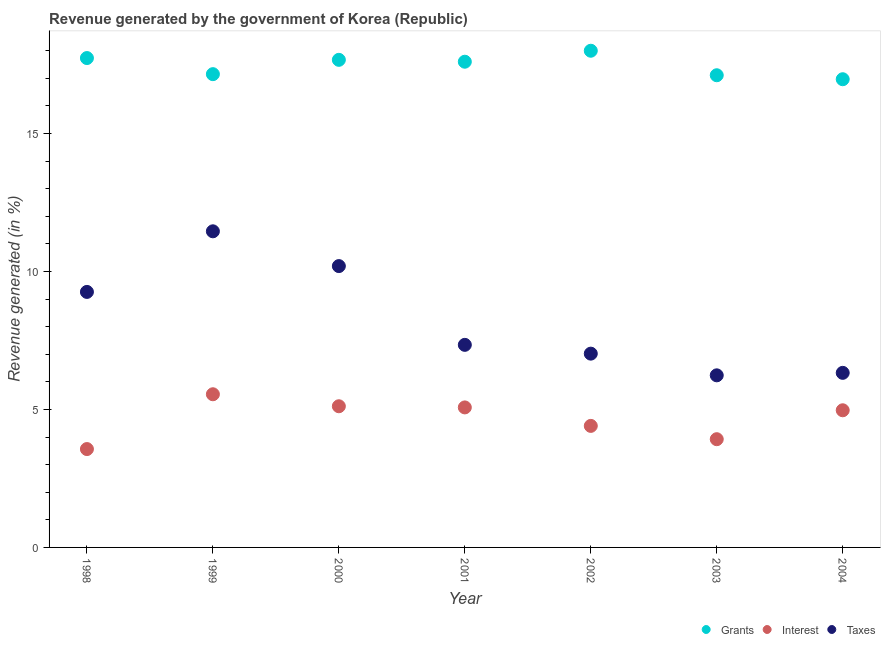Is the number of dotlines equal to the number of legend labels?
Your response must be concise. Yes. What is the percentage of revenue generated by interest in 2002?
Your answer should be compact. 4.4. Across all years, what is the maximum percentage of revenue generated by interest?
Provide a short and direct response. 5.55. Across all years, what is the minimum percentage of revenue generated by interest?
Provide a short and direct response. 3.56. In which year was the percentage of revenue generated by interest minimum?
Offer a very short reply. 1998. What is the total percentage of revenue generated by grants in the graph?
Your answer should be compact. 122.23. What is the difference between the percentage of revenue generated by grants in 2000 and that in 2002?
Offer a terse response. -0.33. What is the difference between the percentage of revenue generated by taxes in 2001 and the percentage of revenue generated by grants in 1998?
Your answer should be compact. -10.39. What is the average percentage of revenue generated by interest per year?
Offer a very short reply. 4.66. In the year 1999, what is the difference between the percentage of revenue generated by grants and percentage of revenue generated by interest?
Your answer should be very brief. 11.6. What is the ratio of the percentage of revenue generated by interest in 1999 to that in 2000?
Offer a terse response. 1.08. Is the percentage of revenue generated by taxes in 2000 less than that in 2002?
Your response must be concise. No. Is the difference between the percentage of revenue generated by taxes in 1998 and 2004 greater than the difference between the percentage of revenue generated by interest in 1998 and 2004?
Make the answer very short. Yes. What is the difference between the highest and the second highest percentage of revenue generated by grants?
Provide a short and direct response. 0.27. What is the difference between the highest and the lowest percentage of revenue generated by grants?
Make the answer very short. 1.03. Is the sum of the percentage of revenue generated by taxes in 2001 and 2003 greater than the maximum percentage of revenue generated by interest across all years?
Ensure brevity in your answer.  Yes. Is the percentage of revenue generated by grants strictly less than the percentage of revenue generated by taxes over the years?
Provide a succinct answer. No. How many dotlines are there?
Offer a terse response. 3. How many years are there in the graph?
Offer a very short reply. 7. Does the graph contain grids?
Your answer should be very brief. No. Where does the legend appear in the graph?
Keep it short and to the point. Bottom right. How many legend labels are there?
Your response must be concise. 3. What is the title of the graph?
Offer a terse response. Revenue generated by the government of Korea (Republic). Does "Ages 20-50" appear as one of the legend labels in the graph?
Your answer should be compact. No. What is the label or title of the Y-axis?
Your answer should be very brief. Revenue generated (in %). What is the Revenue generated (in %) in Grants in 1998?
Ensure brevity in your answer.  17.73. What is the Revenue generated (in %) of Interest in 1998?
Your answer should be very brief. 3.56. What is the Revenue generated (in %) in Taxes in 1998?
Provide a short and direct response. 9.26. What is the Revenue generated (in %) of Grants in 1999?
Ensure brevity in your answer.  17.15. What is the Revenue generated (in %) in Interest in 1999?
Provide a succinct answer. 5.55. What is the Revenue generated (in %) in Taxes in 1999?
Provide a succinct answer. 11.46. What is the Revenue generated (in %) in Grants in 2000?
Keep it short and to the point. 17.67. What is the Revenue generated (in %) of Interest in 2000?
Provide a short and direct response. 5.12. What is the Revenue generated (in %) of Taxes in 2000?
Your answer should be compact. 10.2. What is the Revenue generated (in %) in Grants in 2001?
Provide a succinct answer. 17.6. What is the Revenue generated (in %) in Interest in 2001?
Your answer should be compact. 5.07. What is the Revenue generated (in %) of Taxes in 2001?
Your answer should be compact. 7.34. What is the Revenue generated (in %) of Grants in 2002?
Offer a very short reply. 18. What is the Revenue generated (in %) of Interest in 2002?
Your answer should be compact. 4.4. What is the Revenue generated (in %) of Taxes in 2002?
Your answer should be compact. 7.02. What is the Revenue generated (in %) in Grants in 2003?
Your answer should be very brief. 17.11. What is the Revenue generated (in %) of Interest in 2003?
Provide a short and direct response. 3.92. What is the Revenue generated (in %) of Taxes in 2003?
Keep it short and to the point. 6.24. What is the Revenue generated (in %) in Grants in 2004?
Provide a succinct answer. 16.97. What is the Revenue generated (in %) in Interest in 2004?
Offer a very short reply. 4.97. What is the Revenue generated (in %) of Taxes in 2004?
Offer a very short reply. 6.33. Across all years, what is the maximum Revenue generated (in %) of Grants?
Your answer should be very brief. 18. Across all years, what is the maximum Revenue generated (in %) of Interest?
Keep it short and to the point. 5.55. Across all years, what is the maximum Revenue generated (in %) in Taxes?
Your response must be concise. 11.46. Across all years, what is the minimum Revenue generated (in %) of Grants?
Your answer should be compact. 16.97. Across all years, what is the minimum Revenue generated (in %) in Interest?
Provide a succinct answer. 3.56. Across all years, what is the minimum Revenue generated (in %) in Taxes?
Offer a very short reply. 6.24. What is the total Revenue generated (in %) of Grants in the graph?
Keep it short and to the point. 122.23. What is the total Revenue generated (in %) in Interest in the graph?
Your response must be concise. 32.6. What is the total Revenue generated (in %) of Taxes in the graph?
Ensure brevity in your answer.  57.83. What is the difference between the Revenue generated (in %) of Grants in 1998 and that in 1999?
Your answer should be very brief. 0.58. What is the difference between the Revenue generated (in %) in Interest in 1998 and that in 1999?
Offer a terse response. -1.99. What is the difference between the Revenue generated (in %) of Taxes in 1998 and that in 1999?
Your answer should be compact. -2.2. What is the difference between the Revenue generated (in %) of Grants in 1998 and that in 2000?
Your answer should be very brief. 0.06. What is the difference between the Revenue generated (in %) of Interest in 1998 and that in 2000?
Offer a terse response. -1.55. What is the difference between the Revenue generated (in %) in Taxes in 1998 and that in 2000?
Ensure brevity in your answer.  -0.94. What is the difference between the Revenue generated (in %) of Grants in 1998 and that in 2001?
Offer a terse response. 0.13. What is the difference between the Revenue generated (in %) of Interest in 1998 and that in 2001?
Ensure brevity in your answer.  -1.51. What is the difference between the Revenue generated (in %) in Taxes in 1998 and that in 2001?
Give a very brief answer. 1.92. What is the difference between the Revenue generated (in %) of Grants in 1998 and that in 2002?
Provide a short and direct response. -0.27. What is the difference between the Revenue generated (in %) in Interest in 1998 and that in 2002?
Offer a terse response. -0.84. What is the difference between the Revenue generated (in %) of Taxes in 1998 and that in 2002?
Your response must be concise. 2.24. What is the difference between the Revenue generated (in %) of Grants in 1998 and that in 2003?
Make the answer very short. 0.62. What is the difference between the Revenue generated (in %) in Interest in 1998 and that in 2003?
Provide a short and direct response. -0.36. What is the difference between the Revenue generated (in %) in Taxes in 1998 and that in 2003?
Your answer should be compact. 3.02. What is the difference between the Revenue generated (in %) of Grants in 1998 and that in 2004?
Make the answer very short. 0.77. What is the difference between the Revenue generated (in %) in Interest in 1998 and that in 2004?
Provide a short and direct response. -1.41. What is the difference between the Revenue generated (in %) of Taxes in 1998 and that in 2004?
Ensure brevity in your answer.  2.93. What is the difference between the Revenue generated (in %) in Grants in 1999 and that in 2000?
Your response must be concise. -0.52. What is the difference between the Revenue generated (in %) in Interest in 1999 and that in 2000?
Give a very brief answer. 0.43. What is the difference between the Revenue generated (in %) of Taxes in 1999 and that in 2000?
Your response must be concise. 1.26. What is the difference between the Revenue generated (in %) of Grants in 1999 and that in 2001?
Your answer should be very brief. -0.45. What is the difference between the Revenue generated (in %) of Interest in 1999 and that in 2001?
Your response must be concise. 0.48. What is the difference between the Revenue generated (in %) of Taxes in 1999 and that in 2001?
Provide a short and direct response. 4.11. What is the difference between the Revenue generated (in %) in Grants in 1999 and that in 2002?
Give a very brief answer. -0.85. What is the difference between the Revenue generated (in %) of Interest in 1999 and that in 2002?
Provide a short and direct response. 1.15. What is the difference between the Revenue generated (in %) in Taxes in 1999 and that in 2002?
Your answer should be very brief. 4.43. What is the difference between the Revenue generated (in %) of Grants in 1999 and that in 2003?
Your answer should be compact. 0.04. What is the difference between the Revenue generated (in %) in Interest in 1999 and that in 2003?
Give a very brief answer. 1.63. What is the difference between the Revenue generated (in %) of Taxes in 1999 and that in 2003?
Make the answer very short. 5.22. What is the difference between the Revenue generated (in %) in Grants in 1999 and that in 2004?
Provide a short and direct response. 0.18. What is the difference between the Revenue generated (in %) of Interest in 1999 and that in 2004?
Keep it short and to the point. 0.58. What is the difference between the Revenue generated (in %) of Taxes in 1999 and that in 2004?
Your response must be concise. 5.13. What is the difference between the Revenue generated (in %) in Grants in 2000 and that in 2001?
Ensure brevity in your answer.  0.07. What is the difference between the Revenue generated (in %) in Interest in 2000 and that in 2001?
Give a very brief answer. 0.04. What is the difference between the Revenue generated (in %) of Taxes in 2000 and that in 2001?
Give a very brief answer. 2.85. What is the difference between the Revenue generated (in %) in Grants in 2000 and that in 2002?
Offer a very short reply. -0.33. What is the difference between the Revenue generated (in %) in Interest in 2000 and that in 2002?
Offer a very short reply. 0.71. What is the difference between the Revenue generated (in %) of Taxes in 2000 and that in 2002?
Offer a terse response. 3.17. What is the difference between the Revenue generated (in %) of Grants in 2000 and that in 2003?
Provide a succinct answer. 0.56. What is the difference between the Revenue generated (in %) of Interest in 2000 and that in 2003?
Make the answer very short. 1.19. What is the difference between the Revenue generated (in %) in Taxes in 2000 and that in 2003?
Ensure brevity in your answer.  3.96. What is the difference between the Revenue generated (in %) of Grants in 2000 and that in 2004?
Your response must be concise. 0.7. What is the difference between the Revenue generated (in %) of Interest in 2000 and that in 2004?
Ensure brevity in your answer.  0.15. What is the difference between the Revenue generated (in %) of Taxes in 2000 and that in 2004?
Ensure brevity in your answer.  3.87. What is the difference between the Revenue generated (in %) in Grants in 2001 and that in 2002?
Give a very brief answer. -0.4. What is the difference between the Revenue generated (in %) in Interest in 2001 and that in 2002?
Provide a short and direct response. 0.67. What is the difference between the Revenue generated (in %) in Taxes in 2001 and that in 2002?
Your answer should be compact. 0.32. What is the difference between the Revenue generated (in %) of Grants in 2001 and that in 2003?
Ensure brevity in your answer.  0.49. What is the difference between the Revenue generated (in %) of Interest in 2001 and that in 2003?
Make the answer very short. 1.15. What is the difference between the Revenue generated (in %) of Taxes in 2001 and that in 2003?
Your answer should be very brief. 1.1. What is the difference between the Revenue generated (in %) in Grants in 2001 and that in 2004?
Provide a succinct answer. 0.63. What is the difference between the Revenue generated (in %) in Interest in 2001 and that in 2004?
Your response must be concise. 0.1. What is the difference between the Revenue generated (in %) of Taxes in 2001 and that in 2004?
Your answer should be very brief. 1.01. What is the difference between the Revenue generated (in %) of Grants in 2002 and that in 2003?
Offer a terse response. 0.89. What is the difference between the Revenue generated (in %) in Interest in 2002 and that in 2003?
Your answer should be very brief. 0.48. What is the difference between the Revenue generated (in %) of Taxes in 2002 and that in 2003?
Make the answer very short. 0.79. What is the difference between the Revenue generated (in %) of Grants in 2002 and that in 2004?
Provide a short and direct response. 1.03. What is the difference between the Revenue generated (in %) of Interest in 2002 and that in 2004?
Your answer should be very brief. -0.57. What is the difference between the Revenue generated (in %) of Taxes in 2002 and that in 2004?
Give a very brief answer. 0.7. What is the difference between the Revenue generated (in %) of Grants in 2003 and that in 2004?
Offer a very short reply. 0.14. What is the difference between the Revenue generated (in %) of Interest in 2003 and that in 2004?
Provide a succinct answer. -1.05. What is the difference between the Revenue generated (in %) of Taxes in 2003 and that in 2004?
Keep it short and to the point. -0.09. What is the difference between the Revenue generated (in %) of Grants in 1998 and the Revenue generated (in %) of Interest in 1999?
Your response must be concise. 12.18. What is the difference between the Revenue generated (in %) in Grants in 1998 and the Revenue generated (in %) in Taxes in 1999?
Your answer should be compact. 6.28. What is the difference between the Revenue generated (in %) of Interest in 1998 and the Revenue generated (in %) of Taxes in 1999?
Offer a very short reply. -7.89. What is the difference between the Revenue generated (in %) in Grants in 1998 and the Revenue generated (in %) in Interest in 2000?
Ensure brevity in your answer.  12.62. What is the difference between the Revenue generated (in %) in Grants in 1998 and the Revenue generated (in %) in Taxes in 2000?
Ensure brevity in your answer.  7.54. What is the difference between the Revenue generated (in %) in Interest in 1998 and the Revenue generated (in %) in Taxes in 2000?
Your answer should be very brief. -6.63. What is the difference between the Revenue generated (in %) of Grants in 1998 and the Revenue generated (in %) of Interest in 2001?
Provide a short and direct response. 12.66. What is the difference between the Revenue generated (in %) in Grants in 1998 and the Revenue generated (in %) in Taxes in 2001?
Ensure brevity in your answer.  10.39. What is the difference between the Revenue generated (in %) in Interest in 1998 and the Revenue generated (in %) in Taxes in 2001?
Ensure brevity in your answer.  -3.78. What is the difference between the Revenue generated (in %) of Grants in 1998 and the Revenue generated (in %) of Interest in 2002?
Ensure brevity in your answer.  13.33. What is the difference between the Revenue generated (in %) of Grants in 1998 and the Revenue generated (in %) of Taxes in 2002?
Provide a succinct answer. 10.71. What is the difference between the Revenue generated (in %) of Interest in 1998 and the Revenue generated (in %) of Taxes in 2002?
Keep it short and to the point. -3.46. What is the difference between the Revenue generated (in %) of Grants in 1998 and the Revenue generated (in %) of Interest in 2003?
Provide a short and direct response. 13.81. What is the difference between the Revenue generated (in %) in Grants in 1998 and the Revenue generated (in %) in Taxes in 2003?
Provide a succinct answer. 11.5. What is the difference between the Revenue generated (in %) of Interest in 1998 and the Revenue generated (in %) of Taxes in 2003?
Offer a terse response. -2.67. What is the difference between the Revenue generated (in %) of Grants in 1998 and the Revenue generated (in %) of Interest in 2004?
Provide a short and direct response. 12.76. What is the difference between the Revenue generated (in %) of Grants in 1998 and the Revenue generated (in %) of Taxes in 2004?
Your response must be concise. 11.41. What is the difference between the Revenue generated (in %) in Interest in 1998 and the Revenue generated (in %) in Taxes in 2004?
Make the answer very short. -2.76. What is the difference between the Revenue generated (in %) in Grants in 1999 and the Revenue generated (in %) in Interest in 2000?
Your response must be concise. 12.03. What is the difference between the Revenue generated (in %) of Grants in 1999 and the Revenue generated (in %) of Taxes in 2000?
Offer a terse response. 6.95. What is the difference between the Revenue generated (in %) in Interest in 1999 and the Revenue generated (in %) in Taxes in 2000?
Offer a very short reply. -4.64. What is the difference between the Revenue generated (in %) in Grants in 1999 and the Revenue generated (in %) in Interest in 2001?
Your answer should be very brief. 12.08. What is the difference between the Revenue generated (in %) of Grants in 1999 and the Revenue generated (in %) of Taxes in 2001?
Your response must be concise. 9.81. What is the difference between the Revenue generated (in %) in Interest in 1999 and the Revenue generated (in %) in Taxes in 2001?
Your answer should be compact. -1.79. What is the difference between the Revenue generated (in %) in Grants in 1999 and the Revenue generated (in %) in Interest in 2002?
Ensure brevity in your answer.  12.75. What is the difference between the Revenue generated (in %) in Grants in 1999 and the Revenue generated (in %) in Taxes in 2002?
Your answer should be very brief. 10.13. What is the difference between the Revenue generated (in %) of Interest in 1999 and the Revenue generated (in %) of Taxes in 2002?
Offer a terse response. -1.47. What is the difference between the Revenue generated (in %) of Grants in 1999 and the Revenue generated (in %) of Interest in 2003?
Your answer should be compact. 13.23. What is the difference between the Revenue generated (in %) of Grants in 1999 and the Revenue generated (in %) of Taxes in 2003?
Make the answer very short. 10.91. What is the difference between the Revenue generated (in %) in Interest in 1999 and the Revenue generated (in %) in Taxes in 2003?
Make the answer very short. -0.69. What is the difference between the Revenue generated (in %) in Grants in 1999 and the Revenue generated (in %) in Interest in 2004?
Your answer should be very brief. 12.18. What is the difference between the Revenue generated (in %) of Grants in 1999 and the Revenue generated (in %) of Taxes in 2004?
Offer a terse response. 10.82. What is the difference between the Revenue generated (in %) of Interest in 1999 and the Revenue generated (in %) of Taxes in 2004?
Make the answer very short. -0.78. What is the difference between the Revenue generated (in %) of Grants in 2000 and the Revenue generated (in %) of Interest in 2001?
Provide a succinct answer. 12.6. What is the difference between the Revenue generated (in %) of Grants in 2000 and the Revenue generated (in %) of Taxes in 2001?
Provide a succinct answer. 10.33. What is the difference between the Revenue generated (in %) of Interest in 2000 and the Revenue generated (in %) of Taxes in 2001?
Keep it short and to the point. -2.22. What is the difference between the Revenue generated (in %) in Grants in 2000 and the Revenue generated (in %) in Interest in 2002?
Offer a terse response. 13.26. What is the difference between the Revenue generated (in %) in Grants in 2000 and the Revenue generated (in %) in Taxes in 2002?
Make the answer very short. 10.65. What is the difference between the Revenue generated (in %) of Interest in 2000 and the Revenue generated (in %) of Taxes in 2002?
Your answer should be very brief. -1.91. What is the difference between the Revenue generated (in %) in Grants in 2000 and the Revenue generated (in %) in Interest in 2003?
Keep it short and to the point. 13.75. What is the difference between the Revenue generated (in %) in Grants in 2000 and the Revenue generated (in %) in Taxes in 2003?
Your response must be concise. 11.43. What is the difference between the Revenue generated (in %) in Interest in 2000 and the Revenue generated (in %) in Taxes in 2003?
Offer a terse response. -1.12. What is the difference between the Revenue generated (in %) of Grants in 2000 and the Revenue generated (in %) of Interest in 2004?
Your answer should be very brief. 12.7. What is the difference between the Revenue generated (in %) in Grants in 2000 and the Revenue generated (in %) in Taxes in 2004?
Offer a very short reply. 11.34. What is the difference between the Revenue generated (in %) in Interest in 2000 and the Revenue generated (in %) in Taxes in 2004?
Offer a very short reply. -1.21. What is the difference between the Revenue generated (in %) of Grants in 2001 and the Revenue generated (in %) of Interest in 2002?
Provide a succinct answer. 13.2. What is the difference between the Revenue generated (in %) in Grants in 2001 and the Revenue generated (in %) in Taxes in 2002?
Provide a short and direct response. 10.58. What is the difference between the Revenue generated (in %) of Interest in 2001 and the Revenue generated (in %) of Taxes in 2002?
Your answer should be compact. -1.95. What is the difference between the Revenue generated (in %) of Grants in 2001 and the Revenue generated (in %) of Interest in 2003?
Offer a very short reply. 13.68. What is the difference between the Revenue generated (in %) of Grants in 2001 and the Revenue generated (in %) of Taxes in 2003?
Offer a terse response. 11.36. What is the difference between the Revenue generated (in %) in Interest in 2001 and the Revenue generated (in %) in Taxes in 2003?
Give a very brief answer. -1.16. What is the difference between the Revenue generated (in %) of Grants in 2001 and the Revenue generated (in %) of Interest in 2004?
Ensure brevity in your answer.  12.63. What is the difference between the Revenue generated (in %) in Grants in 2001 and the Revenue generated (in %) in Taxes in 2004?
Your answer should be very brief. 11.27. What is the difference between the Revenue generated (in %) in Interest in 2001 and the Revenue generated (in %) in Taxes in 2004?
Your answer should be very brief. -1.25. What is the difference between the Revenue generated (in %) in Grants in 2002 and the Revenue generated (in %) in Interest in 2003?
Provide a succinct answer. 14.08. What is the difference between the Revenue generated (in %) of Grants in 2002 and the Revenue generated (in %) of Taxes in 2003?
Your answer should be very brief. 11.76. What is the difference between the Revenue generated (in %) of Interest in 2002 and the Revenue generated (in %) of Taxes in 2003?
Your answer should be compact. -1.83. What is the difference between the Revenue generated (in %) in Grants in 2002 and the Revenue generated (in %) in Interest in 2004?
Your answer should be compact. 13.03. What is the difference between the Revenue generated (in %) of Grants in 2002 and the Revenue generated (in %) of Taxes in 2004?
Your answer should be compact. 11.67. What is the difference between the Revenue generated (in %) of Interest in 2002 and the Revenue generated (in %) of Taxes in 2004?
Give a very brief answer. -1.92. What is the difference between the Revenue generated (in %) in Grants in 2003 and the Revenue generated (in %) in Interest in 2004?
Keep it short and to the point. 12.14. What is the difference between the Revenue generated (in %) of Grants in 2003 and the Revenue generated (in %) of Taxes in 2004?
Keep it short and to the point. 10.78. What is the difference between the Revenue generated (in %) in Interest in 2003 and the Revenue generated (in %) in Taxes in 2004?
Make the answer very short. -2.4. What is the average Revenue generated (in %) in Grants per year?
Make the answer very short. 17.46. What is the average Revenue generated (in %) of Interest per year?
Keep it short and to the point. 4.66. What is the average Revenue generated (in %) of Taxes per year?
Your answer should be very brief. 8.26. In the year 1998, what is the difference between the Revenue generated (in %) in Grants and Revenue generated (in %) in Interest?
Provide a succinct answer. 14.17. In the year 1998, what is the difference between the Revenue generated (in %) of Grants and Revenue generated (in %) of Taxes?
Offer a terse response. 8.47. In the year 1998, what is the difference between the Revenue generated (in %) of Interest and Revenue generated (in %) of Taxes?
Provide a succinct answer. -5.69. In the year 1999, what is the difference between the Revenue generated (in %) in Grants and Revenue generated (in %) in Interest?
Your response must be concise. 11.6. In the year 1999, what is the difference between the Revenue generated (in %) of Grants and Revenue generated (in %) of Taxes?
Make the answer very short. 5.69. In the year 1999, what is the difference between the Revenue generated (in %) in Interest and Revenue generated (in %) in Taxes?
Provide a succinct answer. -5.9. In the year 2000, what is the difference between the Revenue generated (in %) in Grants and Revenue generated (in %) in Interest?
Your response must be concise. 12.55. In the year 2000, what is the difference between the Revenue generated (in %) of Grants and Revenue generated (in %) of Taxes?
Provide a succinct answer. 7.47. In the year 2000, what is the difference between the Revenue generated (in %) in Interest and Revenue generated (in %) in Taxes?
Your response must be concise. -5.08. In the year 2001, what is the difference between the Revenue generated (in %) of Grants and Revenue generated (in %) of Interest?
Ensure brevity in your answer.  12.53. In the year 2001, what is the difference between the Revenue generated (in %) in Grants and Revenue generated (in %) in Taxes?
Keep it short and to the point. 10.26. In the year 2001, what is the difference between the Revenue generated (in %) in Interest and Revenue generated (in %) in Taxes?
Your response must be concise. -2.27. In the year 2002, what is the difference between the Revenue generated (in %) in Grants and Revenue generated (in %) in Interest?
Your answer should be compact. 13.59. In the year 2002, what is the difference between the Revenue generated (in %) in Grants and Revenue generated (in %) in Taxes?
Your answer should be compact. 10.98. In the year 2002, what is the difference between the Revenue generated (in %) in Interest and Revenue generated (in %) in Taxes?
Make the answer very short. -2.62. In the year 2003, what is the difference between the Revenue generated (in %) in Grants and Revenue generated (in %) in Interest?
Provide a short and direct response. 13.19. In the year 2003, what is the difference between the Revenue generated (in %) in Grants and Revenue generated (in %) in Taxes?
Your answer should be compact. 10.87. In the year 2003, what is the difference between the Revenue generated (in %) of Interest and Revenue generated (in %) of Taxes?
Offer a terse response. -2.31. In the year 2004, what is the difference between the Revenue generated (in %) in Grants and Revenue generated (in %) in Interest?
Keep it short and to the point. 12. In the year 2004, what is the difference between the Revenue generated (in %) of Grants and Revenue generated (in %) of Taxes?
Keep it short and to the point. 10.64. In the year 2004, what is the difference between the Revenue generated (in %) of Interest and Revenue generated (in %) of Taxes?
Give a very brief answer. -1.36. What is the ratio of the Revenue generated (in %) of Grants in 1998 to that in 1999?
Your response must be concise. 1.03. What is the ratio of the Revenue generated (in %) of Interest in 1998 to that in 1999?
Your response must be concise. 0.64. What is the ratio of the Revenue generated (in %) of Taxes in 1998 to that in 1999?
Keep it short and to the point. 0.81. What is the ratio of the Revenue generated (in %) of Interest in 1998 to that in 2000?
Give a very brief answer. 0.7. What is the ratio of the Revenue generated (in %) in Taxes in 1998 to that in 2000?
Make the answer very short. 0.91. What is the ratio of the Revenue generated (in %) of Grants in 1998 to that in 2001?
Offer a very short reply. 1.01. What is the ratio of the Revenue generated (in %) of Interest in 1998 to that in 2001?
Provide a short and direct response. 0.7. What is the ratio of the Revenue generated (in %) in Taxes in 1998 to that in 2001?
Your answer should be very brief. 1.26. What is the ratio of the Revenue generated (in %) in Grants in 1998 to that in 2002?
Ensure brevity in your answer.  0.99. What is the ratio of the Revenue generated (in %) of Interest in 1998 to that in 2002?
Give a very brief answer. 0.81. What is the ratio of the Revenue generated (in %) in Taxes in 1998 to that in 2002?
Give a very brief answer. 1.32. What is the ratio of the Revenue generated (in %) in Grants in 1998 to that in 2003?
Make the answer very short. 1.04. What is the ratio of the Revenue generated (in %) in Interest in 1998 to that in 2003?
Provide a short and direct response. 0.91. What is the ratio of the Revenue generated (in %) of Taxes in 1998 to that in 2003?
Make the answer very short. 1.48. What is the ratio of the Revenue generated (in %) in Grants in 1998 to that in 2004?
Offer a very short reply. 1.05. What is the ratio of the Revenue generated (in %) of Interest in 1998 to that in 2004?
Your answer should be compact. 0.72. What is the ratio of the Revenue generated (in %) of Taxes in 1998 to that in 2004?
Keep it short and to the point. 1.46. What is the ratio of the Revenue generated (in %) in Grants in 1999 to that in 2000?
Your answer should be very brief. 0.97. What is the ratio of the Revenue generated (in %) of Interest in 1999 to that in 2000?
Offer a terse response. 1.08. What is the ratio of the Revenue generated (in %) of Taxes in 1999 to that in 2000?
Offer a terse response. 1.12. What is the ratio of the Revenue generated (in %) of Grants in 1999 to that in 2001?
Make the answer very short. 0.97. What is the ratio of the Revenue generated (in %) in Interest in 1999 to that in 2001?
Offer a very short reply. 1.09. What is the ratio of the Revenue generated (in %) in Taxes in 1999 to that in 2001?
Keep it short and to the point. 1.56. What is the ratio of the Revenue generated (in %) in Grants in 1999 to that in 2002?
Give a very brief answer. 0.95. What is the ratio of the Revenue generated (in %) of Interest in 1999 to that in 2002?
Keep it short and to the point. 1.26. What is the ratio of the Revenue generated (in %) in Taxes in 1999 to that in 2002?
Offer a very short reply. 1.63. What is the ratio of the Revenue generated (in %) in Grants in 1999 to that in 2003?
Your answer should be very brief. 1. What is the ratio of the Revenue generated (in %) in Interest in 1999 to that in 2003?
Your response must be concise. 1.42. What is the ratio of the Revenue generated (in %) of Taxes in 1999 to that in 2003?
Provide a succinct answer. 1.84. What is the ratio of the Revenue generated (in %) of Grants in 1999 to that in 2004?
Provide a short and direct response. 1.01. What is the ratio of the Revenue generated (in %) in Interest in 1999 to that in 2004?
Give a very brief answer. 1.12. What is the ratio of the Revenue generated (in %) of Taxes in 1999 to that in 2004?
Make the answer very short. 1.81. What is the ratio of the Revenue generated (in %) in Interest in 2000 to that in 2001?
Your answer should be compact. 1.01. What is the ratio of the Revenue generated (in %) of Taxes in 2000 to that in 2001?
Your answer should be compact. 1.39. What is the ratio of the Revenue generated (in %) in Grants in 2000 to that in 2002?
Provide a short and direct response. 0.98. What is the ratio of the Revenue generated (in %) of Interest in 2000 to that in 2002?
Keep it short and to the point. 1.16. What is the ratio of the Revenue generated (in %) of Taxes in 2000 to that in 2002?
Provide a short and direct response. 1.45. What is the ratio of the Revenue generated (in %) of Grants in 2000 to that in 2003?
Keep it short and to the point. 1.03. What is the ratio of the Revenue generated (in %) in Interest in 2000 to that in 2003?
Offer a terse response. 1.3. What is the ratio of the Revenue generated (in %) of Taxes in 2000 to that in 2003?
Your answer should be compact. 1.63. What is the ratio of the Revenue generated (in %) in Grants in 2000 to that in 2004?
Your response must be concise. 1.04. What is the ratio of the Revenue generated (in %) in Interest in 2000 to that in 2004?
Offer a terse response. 1.03. What is the ratio of the Revenue generated (in %) in Taxes in 2000 to that in 2004?
Your response must be concise. 1.61. What is the ratio of the Revenue generated (in %) of Grants in 2001 to that in 2002?
Keep it short and to the point. 0.98. What is the ratio of the Revenue generated (in %) in Interest in 2001 to that in 2002?
Provide a succinct answer. 1.15. What is the ratio of the Revenue generated (in %) in Taxes in 2001 to that in 2002?
Ensure brevity in your answer.  1.05. What is the ratio of the Revenue generated (in %) of Grants in 2001 to that in 2003?
Your response must be concise. 1.03. What is the ratio of the Revenue generated (in %) of Interest in 2001 to that in 2003?
Your answer should be compact. 1.29. What is the ratio of the Revenue generated (in %) of Taxes in 2001 to that in 2003?
Your answer should be very brief. 1.18. What is the ratio of the Revenue generated (in %) in Grants in 2001 to that in 2004?
Offer a very short reply. 1.04. What is the ratio of the Revenue generated (in %) of Interest in 2001 to that in 2004?
Offer a very short reply. 1.02. What is the ratio of the Revenue generated (in %) in Taxes in 2001 to that in 2004?
Your answer should be compact. 1.16. What is the ratio of the Revenue generated (in %) of Grants in 2002 to that in 2003?
Make the answer very short. 1.05. What is the ratio of the Revenue generated (in %) of Interest in 2002 to that in 2003?
Ensure brevity in your answer.  1.12. What is the ratio of the Revenue generated (in %) of Taxes in 2002 to that in 2003?
Offer a very short reply. 1.13. What is the ratio of the Revenue generated (in %) in Grants in 2002 to that in 2004?
Provide a succinct answer. 1.06. What is the ratio of the Revenue generated (in %) of Interest in 2002 to that in 2004?
Your answer should be very brief. 0.89. What is the ratio of the Revenue generated (in %) of Taxes in 2002 to that in 2004?
Your answer should be compact. 1.11. What is the ratio of the Revenue generated (in %) of Grants in 2003 to that in 2004?
Offer a very short reply. 1.01. What is the ratio of the Revenue generated (in %) of Interest in 2003 to that in 2004?
Provide a short and direct response. 0.79. What is the ratio of the Revenue generated (in %) in Taxes in 2003 to that in 2004?
Your response must be concise. 0.99. What is the difference between the highest and the second highest Revenue generated (in %) in Grants?
Ensure brevity in your answer.  0.27. What is the difference between the highest and the second highest Revenue generated (in %) of Interest?
Offer a terse response. 0.43. What is the difference between the highest and the second highest Revenue generated (in %) of Taxes?
Provide a succinct answer. 1.26. What is the difference between the highest and the lowest Revenue generated (in %) of Grants?
Provide a succinct answer. 1.03. What is the difference between the highest and the lowest Revenue generated (in %) of Interest?
Keep it short and to the point. 1.99. What is the difference between the highest and the lowest Revenue generated (in %) of Taxes?
Give a very brief answer. 5.22. 